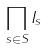<formula> <loc_0><loc_0><loc_500><loc_500>\prod _ { s \in S } I _ { s }</formula> 